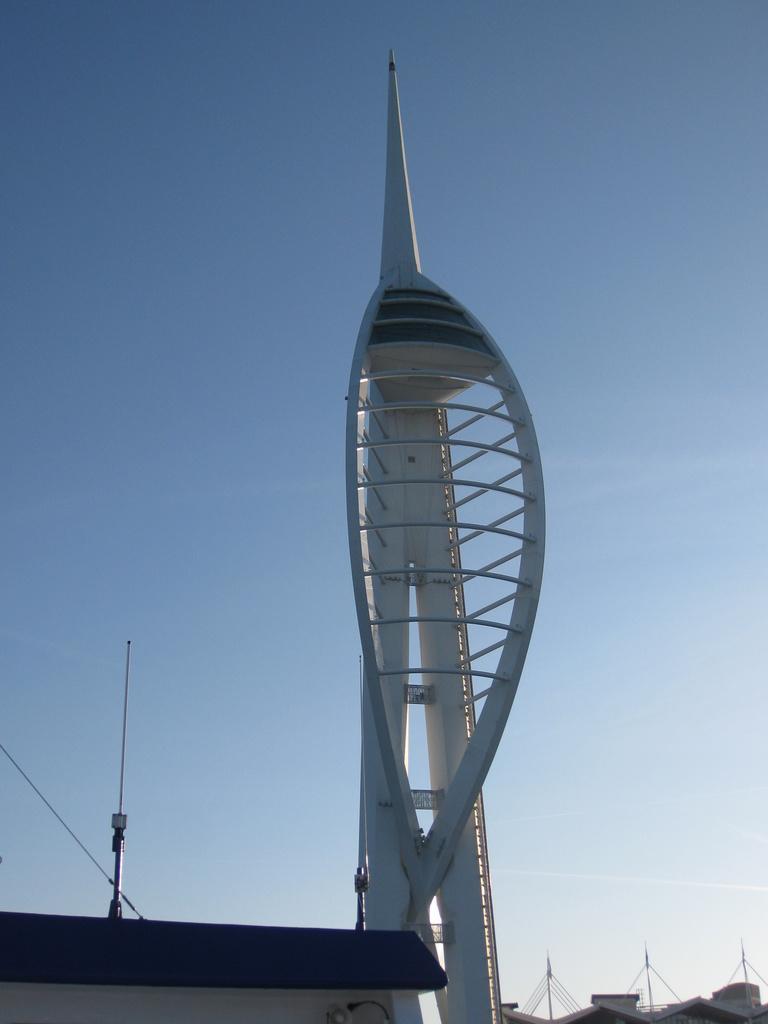How would you summarize this image in a sentence or two? It is a tall tower and there are some poles behind the tower and in the background there is a sky. 